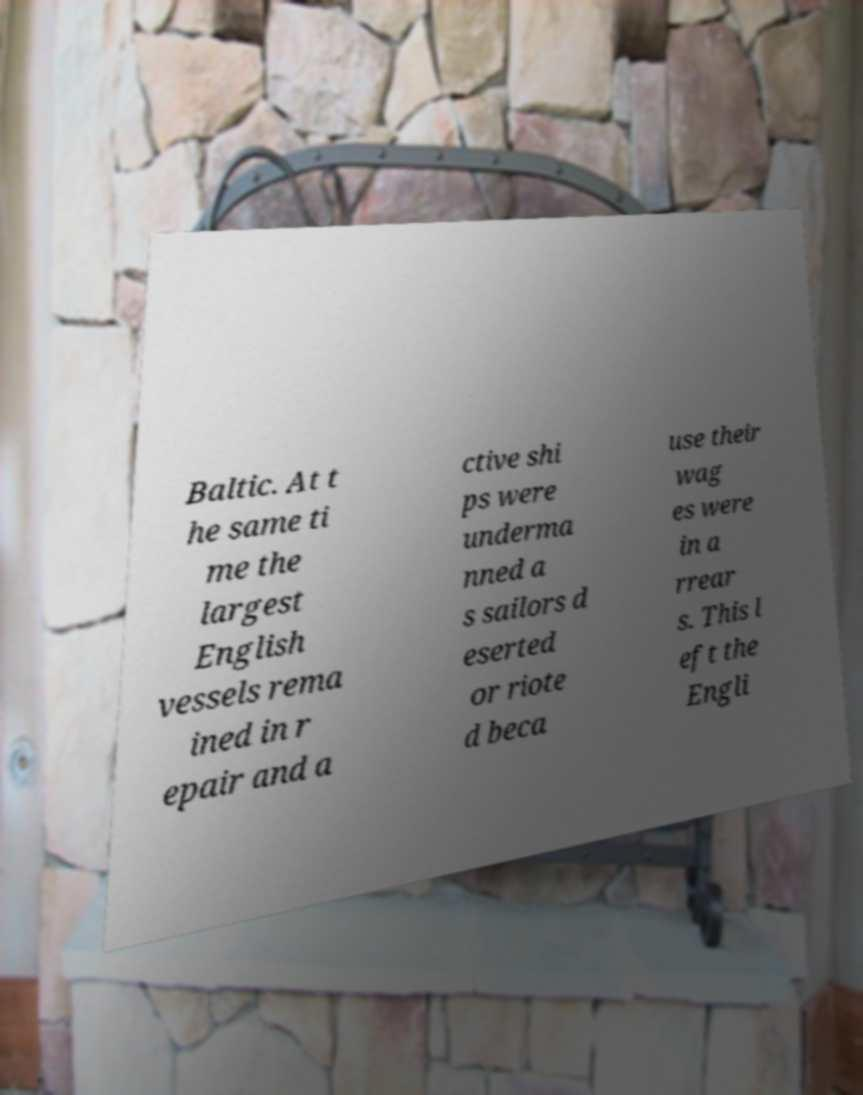For documentation purposes, I need the text within this image transcribed. Could you provide that? Baltic. At t he same ti me the largest English vessels rema ined in r epair and a ctive shi ps were underma nned a s sailors d eserted or riote d beca use their wag es were in a rrear s. This l eft the Engli 